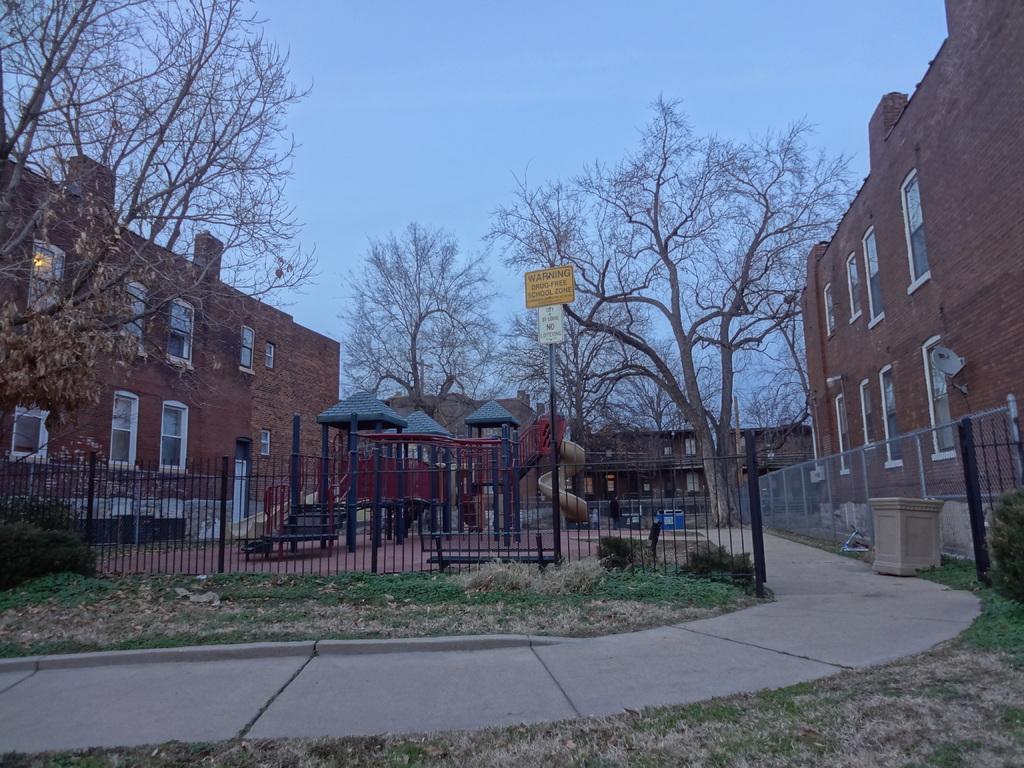Describe this image in one or two sentences. In this image we can see some buildings with windows. We can also see some poles under a roof, a fence, grass, some plants a sign board and a pathway. On the backside we can see some trees and the sky which looks cloudy. 